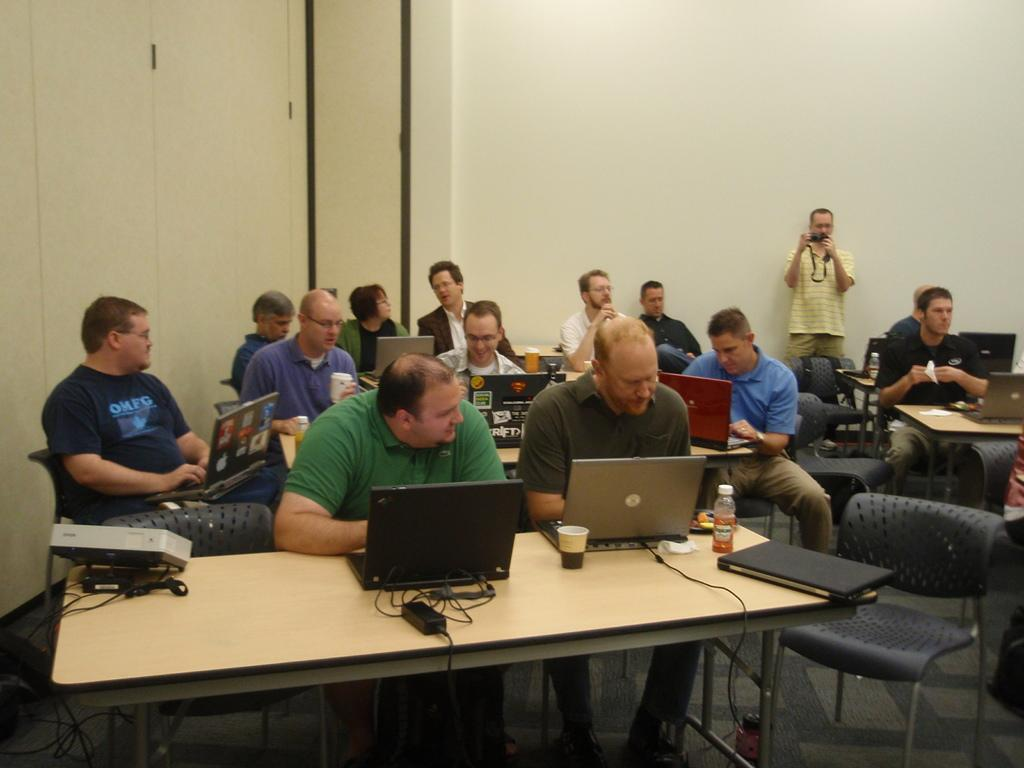How many people are in the image? There is a group of persons in the image. What are the persons in the image doing? The persons are sitting in chairs and operating a laptop. Can you describe the clothing of one of the persons? There is a person wearing a yellow shirt. What is the person wearing a yellow shirt holding? The person wearing a yellow shirt is holding a camera. What type of war is depicted in the image? There is no war depicted in the image; it features a group of persons sitting in chairs and operating a laptop. What type of wax can be seen melting in the image? There is no wax present in the image. 